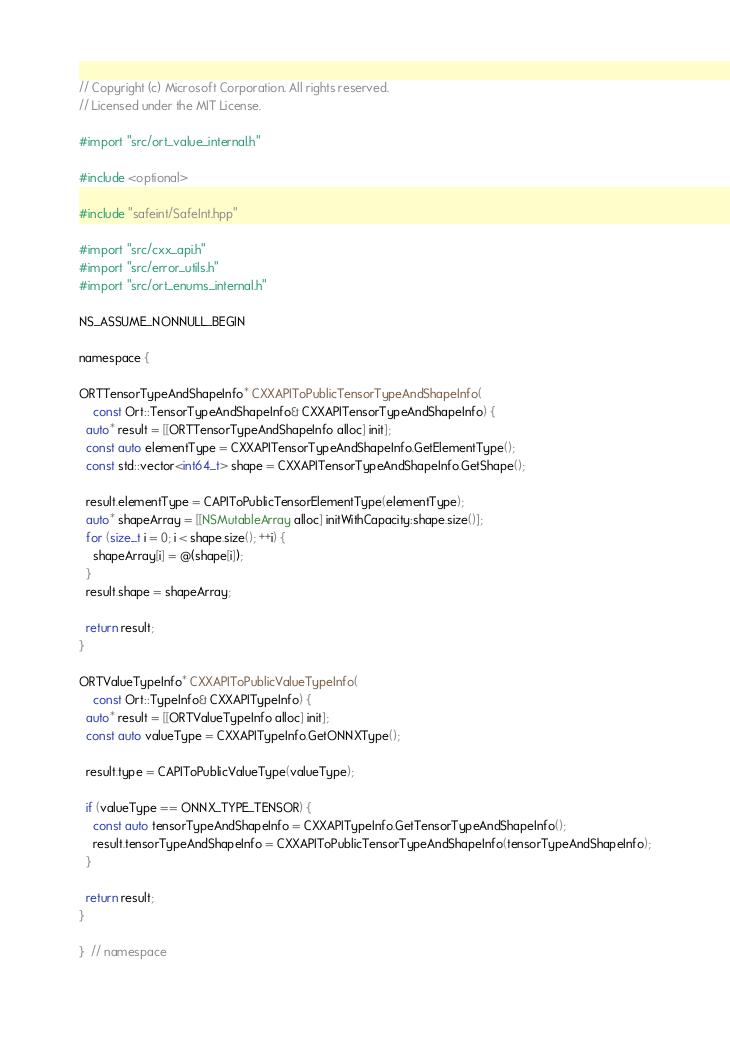<code> <loc_0><loc_0><loc_500><loc_500><_ObjectiveC_>// Copyright (c) Microsoft Corporation. All rights reserved.
// Licensed under the MIT License.

#import "src/ort_value_internal.h"

#include <optional>

#include "safeint/SafeInt.hpp"

#import "src/cxx_api.h"
#import "src/error_utils.h"
#import "src/ort_enums_internal.h"

NS_ASSUME_NONNULL_BEGIN

namespace {

ORTTensorTypeAndShapeInfo* CXXAPIToPublicTensorTypeAndShapeInfo(
    const Ort::TensorTypeAndShapeInfo& CXXAPITensorTypeAndShapeInfo) {
  auto* result = [[ORTTensorTypeAndShapeInfo alloc] init];
  const auto elementType = CXXAPITensorTypeAndShapeInfo.GetElementType();
  const std::vector<int64_t> shape = CXXAPITensorTypeAndShapeInfo.GetShape();

  result.elementType = CAPIToPublicTensorElementType(elementType);
  auto* shapeArray = [[NSMutableArray alloc] initWithCapacity:shape.size()];
  for (size_t i = 0; i < shape.size(); ++i) {
    shapeArray[i] = @(shape[i]);
  }
  result.shape = shapeArray;

  return result;
}

ORTValueTypeInfo* CXXAPIToPublicValueTypeInfo(
    const Ort::TypeInfo& CXXAPITypeInfo) {
  auto* result = [[ORTValueTypeInfo alloc] init];
  const auto valueType = CXXAPITypeInfo.GetONNXType();

  result.type = CAPIToPublicValueType(valueType);

  if (valueType == ONNX_TYPE_TENSOR) {
    const auto tensorTypeAndShapeInfo = CXXAPITypeInfo.GetTensorTypeAndShapeInfo();
    result.tensorTypeAndShapeInfo = CXXAPIToPublicTensorTypeAndShapeInfo(tensorTypeAndShapeInfo);
  }

  return result;
}

}  // namespace
</code> 